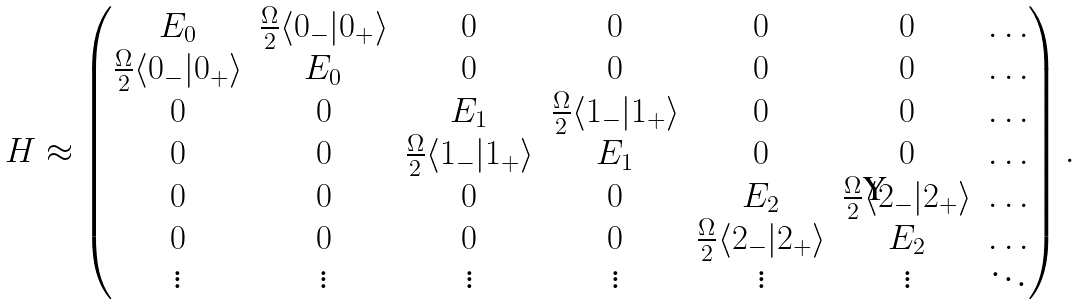Convert formula to latex. <formula><loc_0><loc_0><loc_500><loc_500>H \approx \begin{pmatrix} E _ { 0 } & \frac { \Omega } { 2 } \langle 0 _ { - } | 0 _ { + } \rangle & 0 & 0 & 0 & 0 & \dots \\ \frac { \Omega } { 2 } \langle 0 _ { - } | 0 _ { + } \rangle & E _ { 0 } & 0 & 0 & 0 & 0 & \dots \\ 0 & 0 & E _ { 1 } & \frac { \Omega } { 2 } \langle 1 _ { - } | 1 _ { + } \rangle & 0 & 0 & \dots \\ 0 & 0 & \frac { \Omega } { 2 } \langle 1 _ { - } | 1 _ { + } \rangle & E _ { 1 } & 0 & 0 & \dots \\ 0 & 0 & 0 & 0 & E _ { 2 } & \frac { \Omega } { 2 } \langle 2 _ { - } | 2 _ { + } \rangle & \dots \\ 0 & 0 & 0 & 0 & \frac { \Omega } { 2 } \langle 2 _ { - } | 2 _ { + } \rangle & E _ { 2 } & \dots \\ \vdots & \vdots & \vdots & \vdots & \vdots & \vdots & \ddots \end{pmatrix} .</formula> 